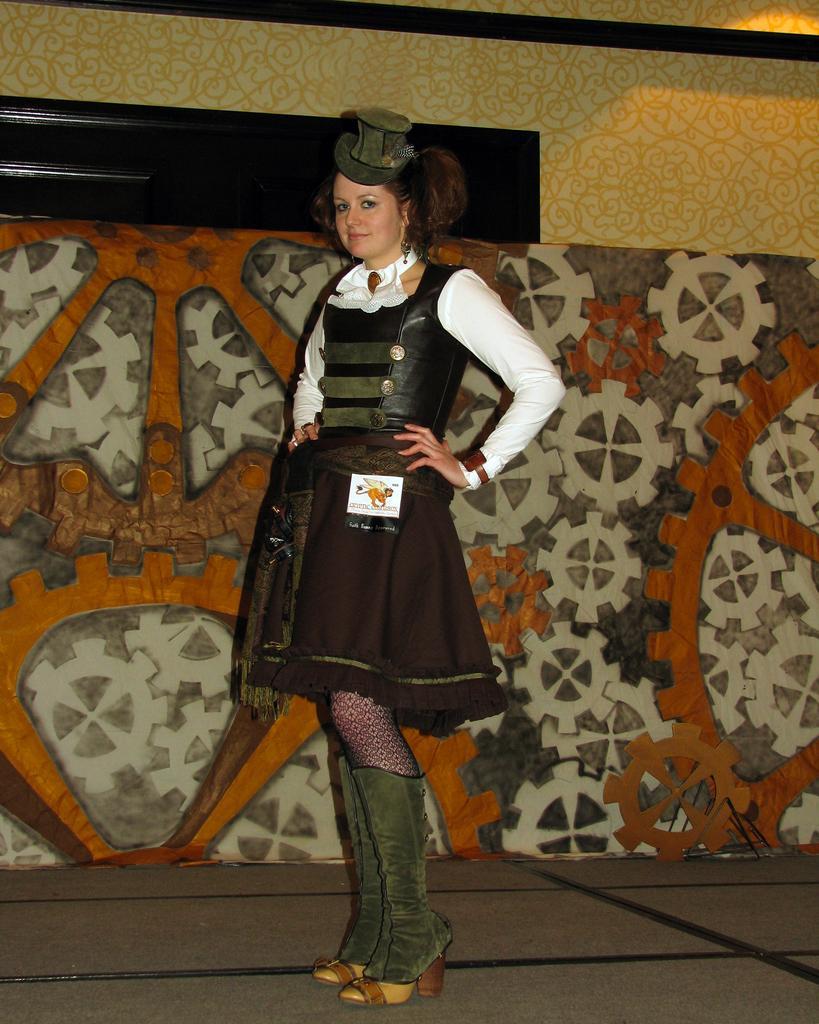Describe this image in one or two sentences. Here in this picture we can see a woman standing over a place and we can see she is wearing a hat on her and behind her we can see a wall designed in a way present over there. 